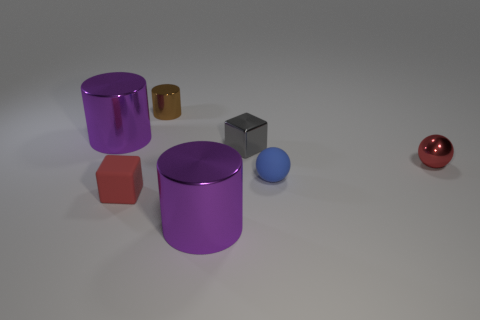What number of small brown objects have the same material as the gray block? In the image provided, there are three small brown objects present, which appear to be of a similar smooth and matte finish as the gray block, suggesting that they potentially share the same material. However, without being able to physically examine the objects, it's not possible to ascertain with complete certainty that their material composition is identical. 